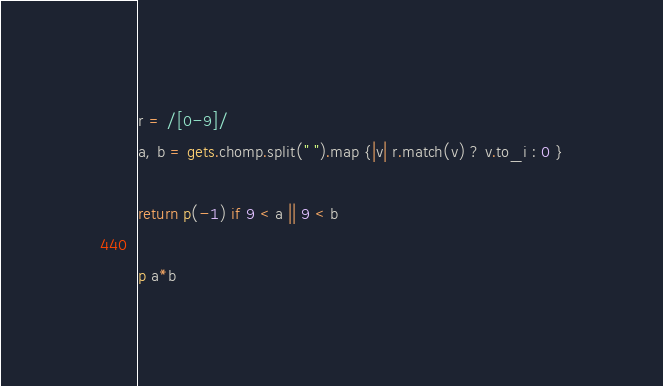Convert code to text. <code><loc_0><loc_0><loc_500><loc_500><_Ruby_>r = /[0-9]/
a, b = gets.chomp.split(" ").map {|v| r.match(v) ? v.to_i : 0 }

return p(-1) if 9 < a || 9 < b

p a*b</code> 